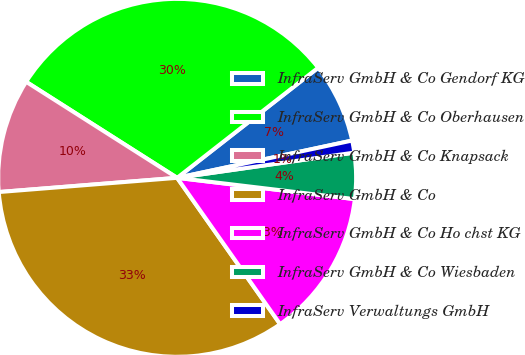Convert chart. <chart><loc_0><loc_0><loc_500><loc_500><pie_chart><fcel>InfraServ GmbH & Co Gendorf KG<fcel>InfraServ GmbH & Co Oberhausen<fcel>InfraServ GmbH & Co Knapsack<fcel>InfraServ GmbH & Co<fcel>InfraServ GmbH & Co Ho chst KG<fcel>InfraServ GmbH & Co Wiesbaden<fcel>InfraServ Verwaltungs GmbH<nl><fcel>7.21%<fcel>30.43%<fcel>10.28%<fcel>33.49%<fcel>13.34%<fcel>4.15%<fcel>1.09%<nl></chart> 